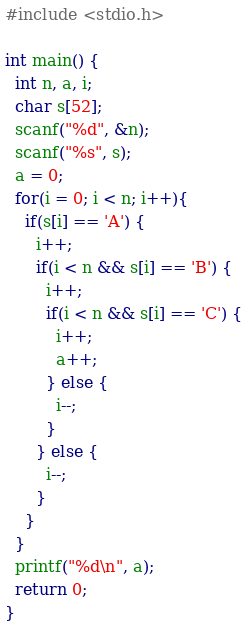Convert code to text. <code><loc_0><loc_0><loc_500><loc_500><_C_>#include <stdio.h>

int main() {
  int n, a, i;
  char s[52];
  scanf("%d", &n);
  scanf("%s", s);
  a = 0;
  for(i = 0; i < n; i++){
    if(s[i] == 'A') {
      i++;
      if(i < n && s[i] == 'B') {
        i++;
        if(i < n && s[i] == 'C') {
          i++;
          a++;
        } else {
          i--;
        }
      } else {
        i--;
      }
    }
  }
  printf("%d\n", a);
  return 0;
}
</code> 